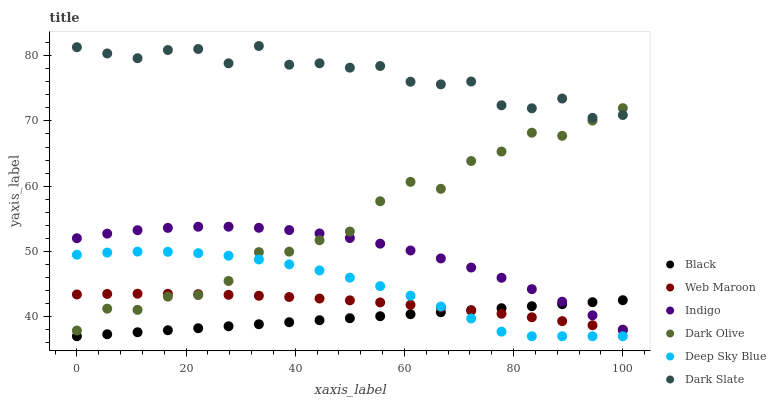Does Black have the minimum area under the curve?
Answer yes or no. Yes. Does Dark Slate have the maximum area under the curve?
Answer yes or no. Yes. Does Dark Olive have the minimum area under the curve?
Answer yes or no. No. Does Dark Olive have the maximum area under the curve?
Answer yes or no. No. Is Black the smoothest?
Answer yes or no. Yes. Is Dark Slate the roughest?
Answer yes or no. Yes. Is Dark Olive the smoothest?
Answer yes or no. No. Is Dark Olive the roughest?
Answer yes or no. No. Does Black have the lowest value?
Answer yes or no. Yes. Does Dark Olive have the lowest value?
Answer yes or no. No. Does Dark Slate have the highest value?
Answer yes or no. Yes. Does Dark Olive have the highest value?
Answer yes or no. No. Is Deep Sky Blue less than Indigo?
Answer yes or no. Yes. Is Dark Slate greater than Indigo?
Answer yes or no. Yes. Does Web Maroon intersect Indigo?
Answer yes or no. Yes. Is Web Maroon less than Indigo?
Answer yes or no. No. Is Web Maroon greater than Indigo?
Answer yes or no. No. Does Deep Sky Blue intersect Indigo?
Answer yes or no. No. 